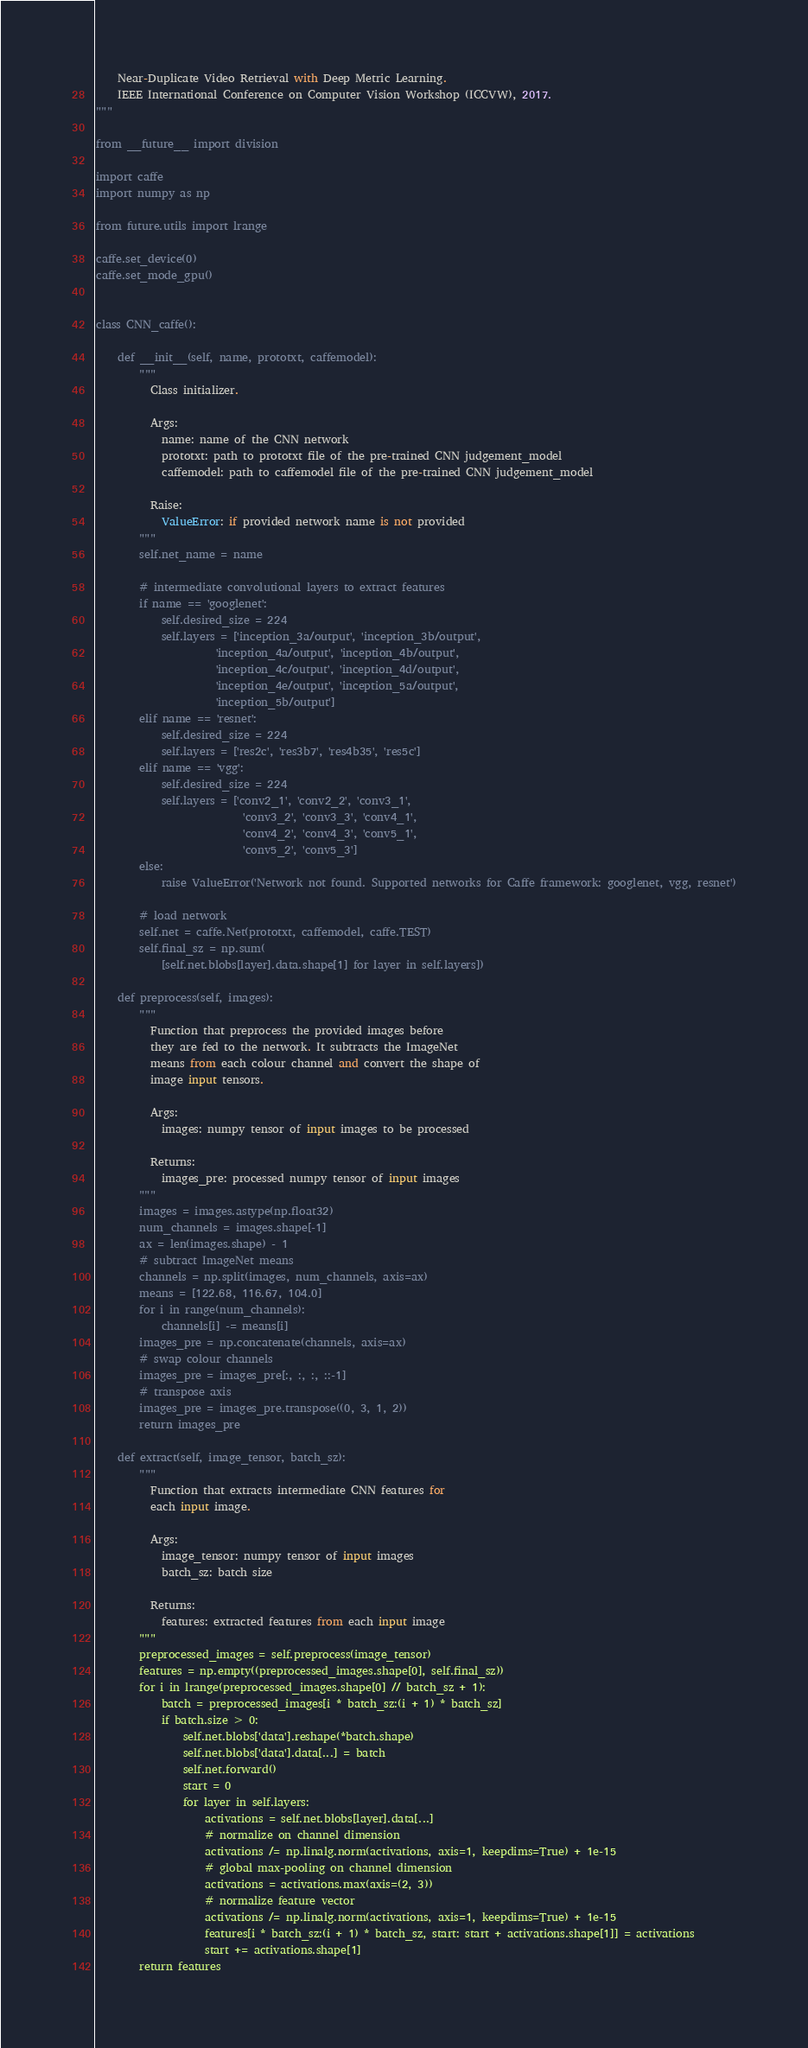<code> <loc_0><loc_0><loc_500><loc_500><_Python_>    Near-Duplicate Video Retrieval with Deep Metric Learning.
    IEEE International Conference on Computer Vision Workshop (ICCVW), 2017.
"""

from __future__ import division

import caffe
import numpy as np

from future.utils import lrange

caffe.set_device(0)
caffe.set_mode_gpu()


class CNN_caffe():

    def __init__(self, name, prototxt, caffemodel):
        """
          Class initializer.

          Args:
            name: name of the CNN network
            prototxt: path to prototxt file of the pre-trained CNN judgement_model
            caffemodel: path to caffemodel file of the pre-trained CNN judgement_model

          Raise:
            ValueError: if provided network name is not provided
        """
        self.net_name = name

        # intermediate convolutional layers to extract features
        if name == 'googlenet':
            self.desired_size = 224
            self.layers = ['inception_3a/output', 'inception_3b/output',
                      'inception_4a/output', 'inception_4b/output',
                      'inception_4c/output', 'inception_4d/output',
                      'inception_4e/output', 'inception_5a/output',
                      'inception_5b/output']
        elif name == 'resnet':
            self.desired_size = 224
            self.layers = ['res2c', 'res3b7', 'res4b35', 'res5c']
        elif name == 'vgg':
            self.desired_size = 224
            self.layers = ['conv2_1', 'conv2_2', 'conv3_1',
                           'conv3_2', 'conv3_3', 'conv4_1',
                           'conv4_2', 'conv4_3', 'conv5_1',
                           'conv5_2', 'conv5_3']
        else:
            raise ValueError('Network not found. Supported networks for Caffe framework: googlenet, vgg, resnet')

        # load network
        self.net = caffe.Net(prototxt, caffemodel, caffe.TEST)
        self.final_sz = np.sum(
            [self.net.blobs[layer].data.shape[1] for layer in self.layers])

    def preprocess(self, images):
        """
          Function that preprocess the provided images before
          they are fed to the network. It subtracts the ImageNet
          means from each colour channel and convert the shape of
          image input tensors.

          Args:
            images: numpy tensor of input images to be processed

          Returns:
            images_pre: processed numpy tensor of input images
        """
        images = images.astype(np.float32)
        num_channels = images.shape[-1]
        ax = len(images.shape) - 1
        # subtract ImageNet means
        channels = np.split(images, num_channels, axis=ax)
        means = [122.68, 116.67, 104.0]
        for i in range(num_channels):
            channels[i] -= means[i]
        images_pre = np.concatenate(channels, axis=ax)
        # swap colour channels
        images_pre = images_pre[:, :, :, ::-1]
        # transpose axis
        images_pre = images_pre.transpose((0, 3, 1, 2))
        return images_pre

    def extract(self, image_tensor, batch_sz):
        """
          Function that extracts intermediate CNN features for
          each input image.

          Args:
            image_tensor: numpy tensor of input images
            batch_sz: batch size

          Returns:
            features: extracted features from each input image
        """
        preprocessed_images = self.preprocess(image_tensor)
        features = np.empty((preprocessed_images.shape[0], self.final_sz))
        for i in lrange(preprocessed_images.shape[0] // batch_sz + 1):
            batch = preprocessed_images[i * batch_sz:(i + 1) * batch_sz]
            if batch.size > 0:
                self.net.blobs['data'].reshape(*batch.shape)
                self.net.blobs['data'].data[...] = batch
                self.net.forward()
                start = 0
                for layer in self.layers:
                    activations = self.net.blobs[layer].data[...]
                    # normalize on channel dimension
                    activations /= np.linalg.norm(activations, axis=1, keepdims=True) + 1e-15
                    # global max-pooling on channel dimension
                    activations = activations.max(axis=(2, 3))
                    # normalize feature vector
                    activations /= np.linalg.norm(activations, axis=1, keepdims=True) + 1e-15
                    features[i * batch_sz:(i + 1) * batch_sz, start: start + activations.shape[1]] = activations
                    start += activations.shape[1]
        return features
</code> 